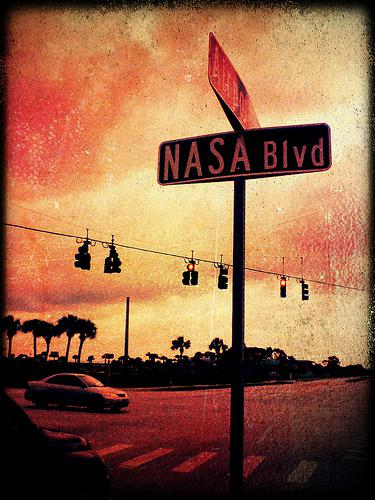Question: what is on the pole?
Choices:
A. Street signs.
B. Missing flyers.
C. Stickers.
D. A monkey.
Answer with the letter. Answer: A Question: where are the signs?
Choices:
A. Next to road.
B. On the pole.
C. Above road.
D. In the windows.
Answer with the letter. Answer: B Question: what does the sign say?
Choices:
A. NASA Blvd.
B. Yard sale.
C. Missing dog.
D. For sale.
Answer with the letter. Answer: A Question: what is on the road?
Choices:
A. A bus.
B. A bike.
C. A car.
D. A scooer.
Answer with the letter. Answer: C Question: why is there a pole?
Choices:
A. To support the signs.
B. To stick your tongue on.
C. To hold up a tent.
D. To seperate areas.
Answer with the letter. Answer: A 